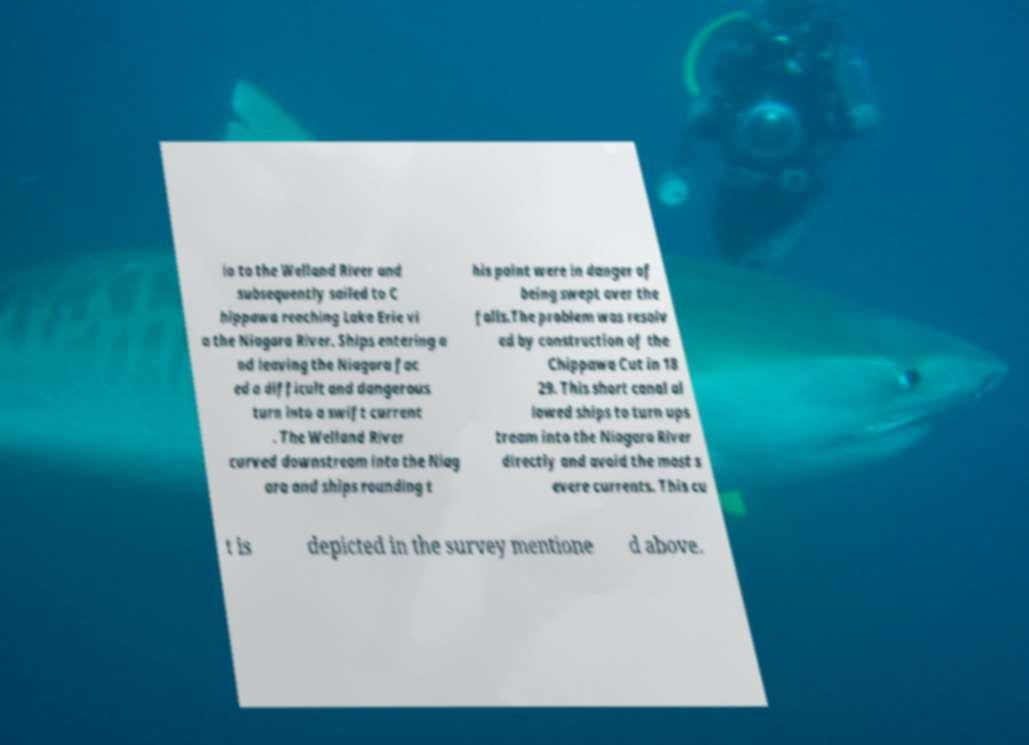For documentation purposes, I need the text within this image transcribed. Could you provide that? io to the Welland River and subsequently sailed to C hippawa reaching Lake Erie vi a the Niagara River. Ships entering a nd leaving the Niagara fac ed a difficult and dangerous turn into a swift current . The Welland River curved downstream into the Niag ara and ships rounding t his point were in danger of being swept over the falls.The problem was resolv ed by construction of the Chippawa Cut in 18 29. This short canal al lowed ships to turn ups tream into the Niagara River directly and avoid the most s evere currents. This cu t is depicted in the survey mentione d above. 